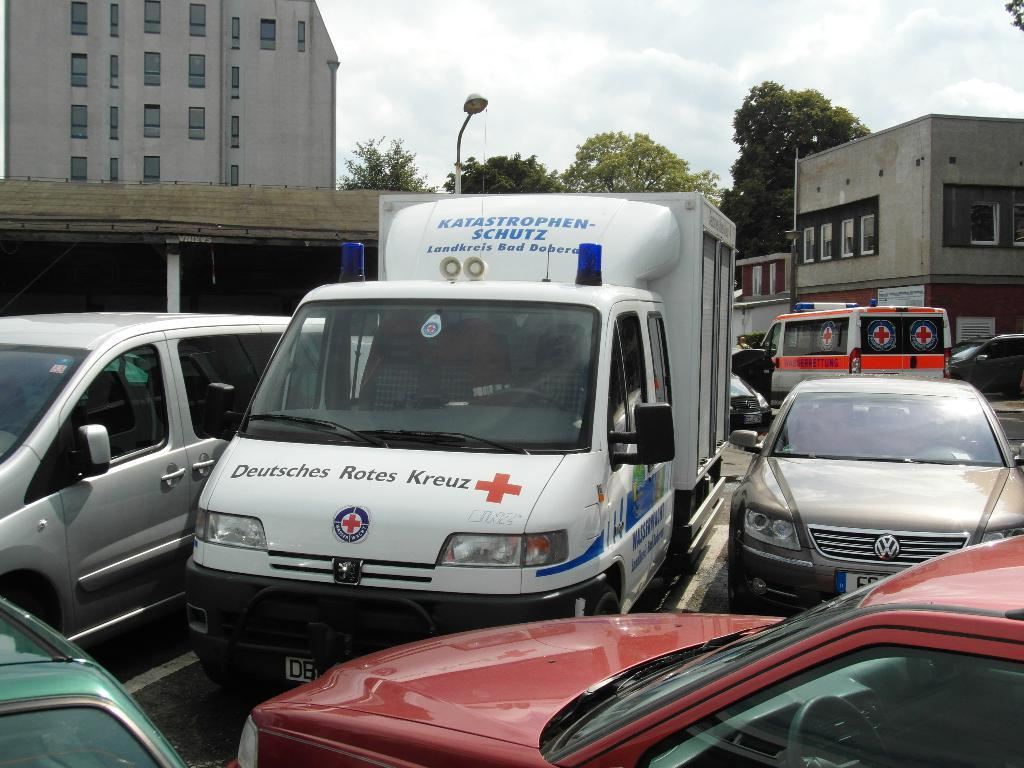What can be seen on the road in the image? There are vehicles on the road in the image. What feature do the buildings in the image have? The buildings in the image have windows. What type of natural vegetation is visible in the image? There are trees visible in the image. What is visible in the background of the image? The sky is visible in the background of the image. What can be observed in the sky? Clouds are present in the sky. How much money is being exchanged between the vehicles in the image? There is no indication of money being exchanged between the vehicles in the image. What type of voyage is being depicted in the image? There is no voyage depicted in the image; it shows vehicles on a road, buildings, trees, and the sky. 